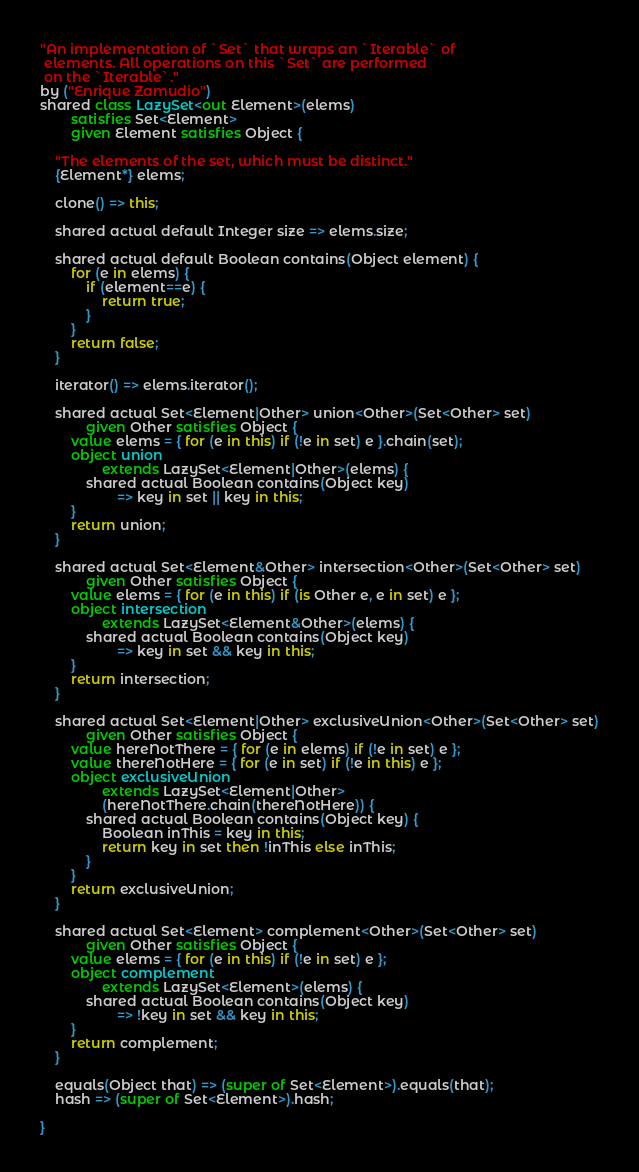<code> <loc_0><loc_0><loc_500><loc_500><_Ceylon_>"An implementation of `Set` that wraps an `Iterable` of
 elements. All operations on this `Set` are performed
 on the `Iterable`."
by ("Enrique Zamudio")
shared class LazySet<out Element>(elems)
        satisfies Set<Element>
        given Element satisfies Object {
    
    "The elements of the set, which must be distinct."
    {Element*} elems;
    
    clone() => this;
    
    shared actual default Integer size => elems.size;
    
    shared actual default Boolean contains(Object element) {
        for (e in elems) {
            if (element==e) {
                return true;
            }
        }
        return false;
    }
    
    iterator() => elems.iterator();
    
    shared actual Set<Element|Other> union<Other>(Set<Other> set)
            given Other satisfies Object {
        value elems = { for (e in this) if (!e in set) e }.chain(set);
        object union 
                extends LazySet<Element|Other>(elems) {
            shared actual Boolean contains(Object key) 
                    => key in set || key in this;
        }
        return union;
    }
    
    shared actual Set<Element&Other> intersection<Other>(Set<Other> set)
            given Other satisfies Object {
        value elems = { for (e in this) if (is Other e, e in set) e };
        object intersection 
                extends LazySet<Element&Other>(elems) {
            shared actual Boolean contains(Object key) 
                    => key in set && key in this;
        }
        return intersection;
    }
    
    shared actual Set<Element|Other> exclusiveUnion<Other>(Set<Other> set)
            given Other satisfies Object {
        value hereNotThere = { for (e in elems) if (!e in set) e };
        value thereNotHere = { for (e in set) if (!e in this) e };
        object exclusiveUnion 
                extends LazySet<Element|Other>
                (hereNotThere.chain(thereNotHere)) {
            shared actual Boolean contains(Object key) {
                Boolean inThis = key in this;
                return key in set then !inThis else inThis;
            }
        }
        return exclusiveUnion;
    }
    
    shared actual Set<Element> complement<Other>(Set<Other> set)
            given Other satisfies Object {
        value elems = { for (e in this) if (!e in set) e };
        object complement 
                extends LazySet<Element>(elems) {
            shared actual Boolean contains(Object key) 
                    => !key in set && key in this;
        }
        return complement;
    }
    
    equals(Object that) => (super of Set<Element>).equals(that);
    hash => (super of Set<Element>).hash;
    
}

</code> 